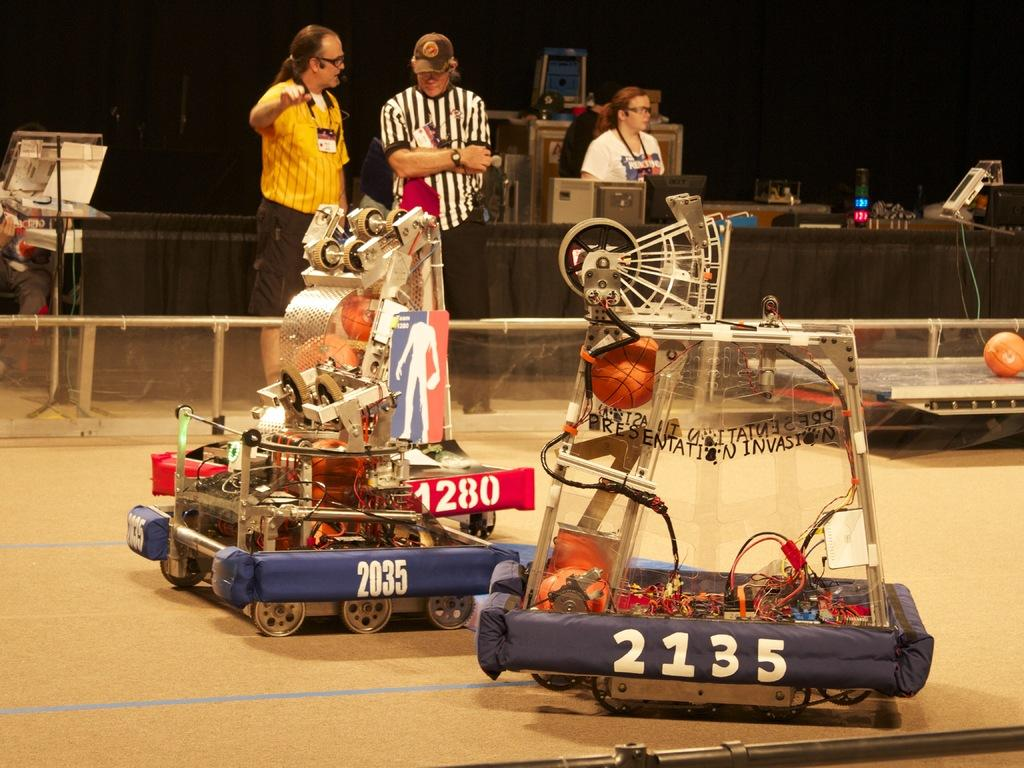What can be found on the floor in the image? There are machines on the floor in the image. Can you describe the people visible in the image? There are people visible in the image. What is covering the table in the image? There is a tablecloth in the image. What type of electronic device is present in the image? A monitor is present in the image. What is the shape of the object that is not a machine or a person? There is a ball in the image. What else can be seen in the image besides the machines, people, tablecloth, monitor, and ball? There are other objects in the image. How would you describe the lighting in the image? The background of the image is dark. How many fans are visible in the image? There are no fans present in the image. Can you describe the tramp in the image? There is no tramp present in the image. 